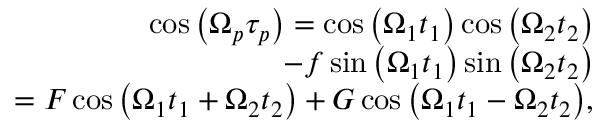Convert formula to latex. <formula><loc_0><loc_0><loc_500><loc_500>\begin{array} { r l r } & { \cos { \left ( { \Omega } _ { p } \tau _ { p } \right ) } = \cos { \left ( \Omega _ { 1 } t _ { 1 } \right ) } \cos { \left ( \Omega _ { 2 } t _ { 2 } \right ) } } \\ & { - f \sin { \left ( \Omega _ { 1 } t _ { 1 } \right ) } \sin { \left ( \Omega _ { 2 } t _ { 2 } \right ) } } \\ & { = F \cos { \left ( \Omega _ { 1 } t _ { 1 } + \Omega _ { 2 } t _ { 2 } \right ) } + G \cos { \left ( \Omega _ { 1 } t _ { 1 } - \Omega _ { 2 } t _ { 2 } \right ) } , } \end{array}</formula> 